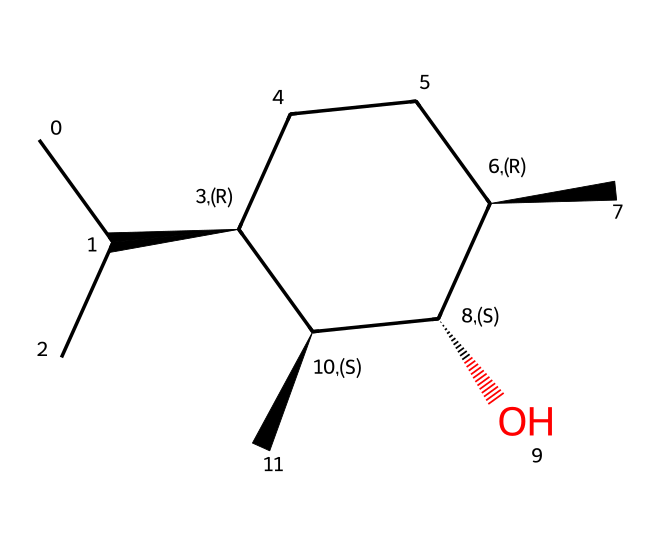What is the molecular formula of menthol? The molecular formula can be derived by counting each type of atom present in the structure represented by the SMILES. The carbon atoms (C) are counted as 10, hydrogen atoms (H) as 20, and one oxygen atom (O) leads to the formula C10H20O.
Answer: C10H20O How many chiral centers are in menthol? Chiral centers are identified by looking at carbon atoms bonded to four different substituents. In menthol, there are three chiral centers, which are the carbons indicated in the structure with stereochemistry (@).
Answer: 3 What functional group is present in menthol? By examining the structure, the presence of a hydroxyl (-OH) group indicates it is an alcohol. The oxygen is bonded to a carbon chain, confirming it as a functional group.
Answer: alcohol How many carbon atoms form the cyclic structure in menthol? The cyclic portion of menthol consists of six carbon atoms that create the ring, which can be visualized within the structure.
Answer: 6 What type of compound is menthol classified as? Menthol is classified under cycloalkanes due to its cyclic structure and being saturated (no double bonds between carbon atoms), following the general characteristics of cycloalkanes.
Answer: cycloalkane Does menthol have any double bonds? By analyzing the structure, all carbon-carbon connections are single bonds, confirming it is fully saturated without double bonds present.
Answer: no 